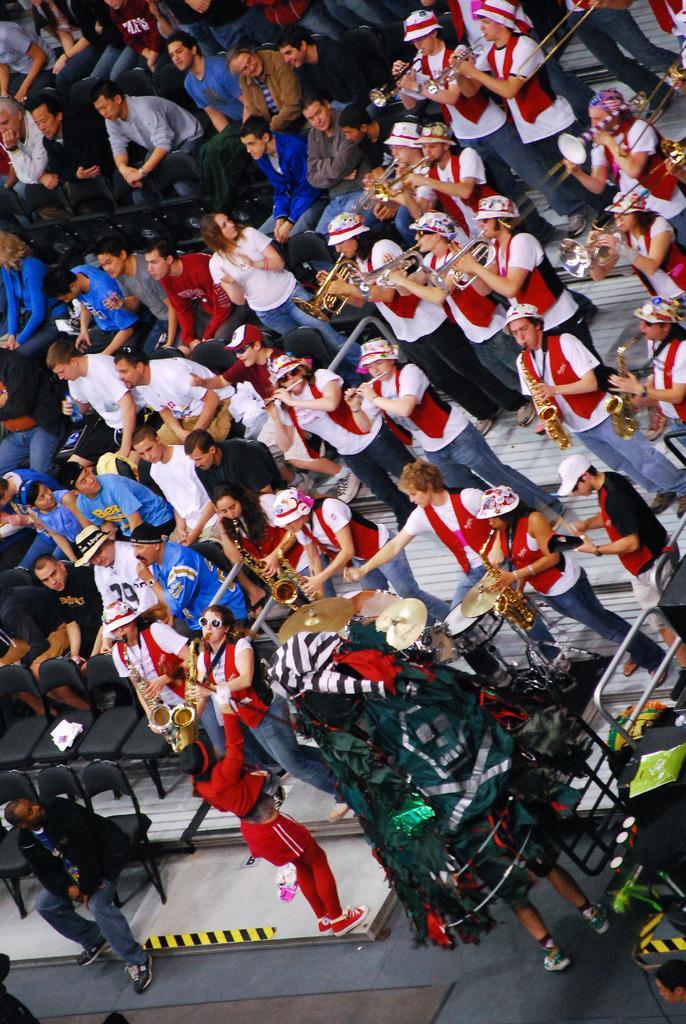In one or two sentences, can you explain what this image depicts? In this picture we can see a group of people where some are sitting on chairs and some are standing on steps and playing musical instruments. 